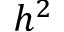Convert formula to latex. <formula><loc_0><loc_0><loc_500><loc_500>h ^ { 2 }</formula> 